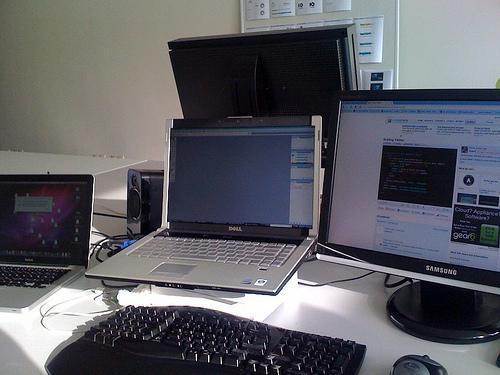How many laptops are in the picture?
Give a very brief answer. 2. How many keyboards are there?
Give a very brief answer. 2. How many tvs are there?
Give a very brief answer. 3. How many people are lifting bags of bananas?
Give a very brief answer. 0. 